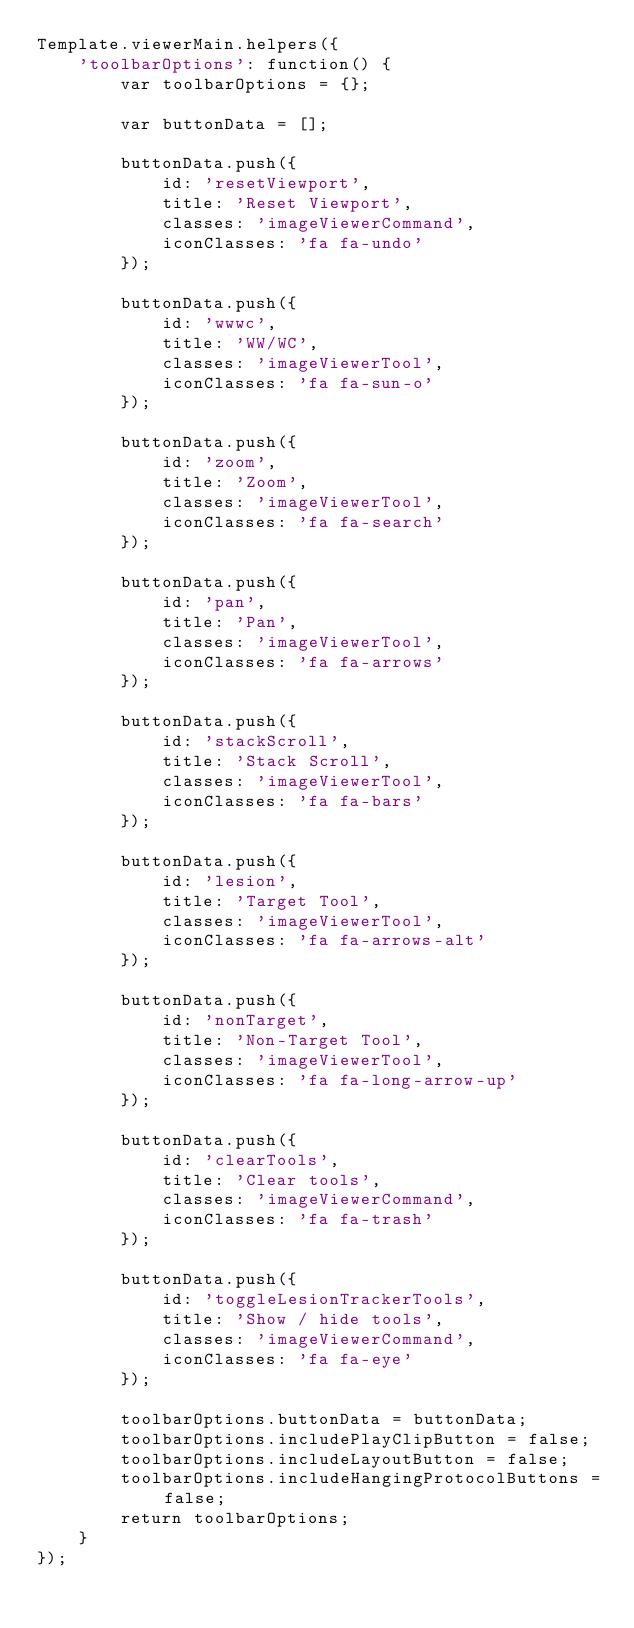Convert code to text. <code><loc_0><loc_0><loc_500><loc_500><_JavaScript_>Template.viewerMain.helpers({
    'toolbarOptions': function() {
        var toolbarOptions = {};

        var buttonData = [];

        buttonData.push({
            id: 'resetViewport',
            title: 'Reset Viewport',
            classes: 'imageViewerCommand',
            iconClasses: 'fa fa-undo'
        });

        buttonData.push({
            id: 'wwwc',
            title: 'WW/WC',
            classes: 'imageViewerTool',
            iconClasses: 'fa fa-sun-o'
        });

        buttonData.push({
            id: 'zoom',
            title: 'Zoom',
            classes: 'imageViewerTool',
            iconClasses: 'fa fa-search'
        });

        buttonData.push({
            id: 'pan',
            title: 'Pan',
            classes: 'imageViewerTool',
            iconClasses: 'fa fa-arrows'
        });

        buttonData.push({
            id: 'stackScroll',
            title: 'Stack Scroll',
            classes: 'imageViewerTool',
            iconClasses: 'fa fa-bars'
        });

        buttonData.push({
            id: 'lesion',
            title: 'Target Tool',
            classes: 'imageViewerTool',
            iconClasses: 'fa fa-arrows-alt'
        });

        buttonData.push({
            id: 'nonTarget',
            title: 'Non-Target Tool',
            classes: 'imageViewerTool',
            iconClasses: 'fa fa-long-arrow-up'
        });

        buttonData.push({
            id: 'clearTools',
            title: 'Clear tools',
            classes: 'imageViewerCommand',
            iconClasses: 'fa fa-trash'
        });

        buttonData.push({
            id: 'toggleLesionTrackerTools',
            title: 'Show / hide tools',
            classes: 'imageViewerCommand',
            iconClasses: 'fa fa-eye'
        });

        toolbarOptions.buttonData = buttonData;
        toolbarOptions.includePlayClipButton = false;
        toolbarOptions.includeLayoutButton = false;
        toolbarOptions.includeHangingProtocolButtons = false;
        return toolbarOptions;
    }
});</code> 